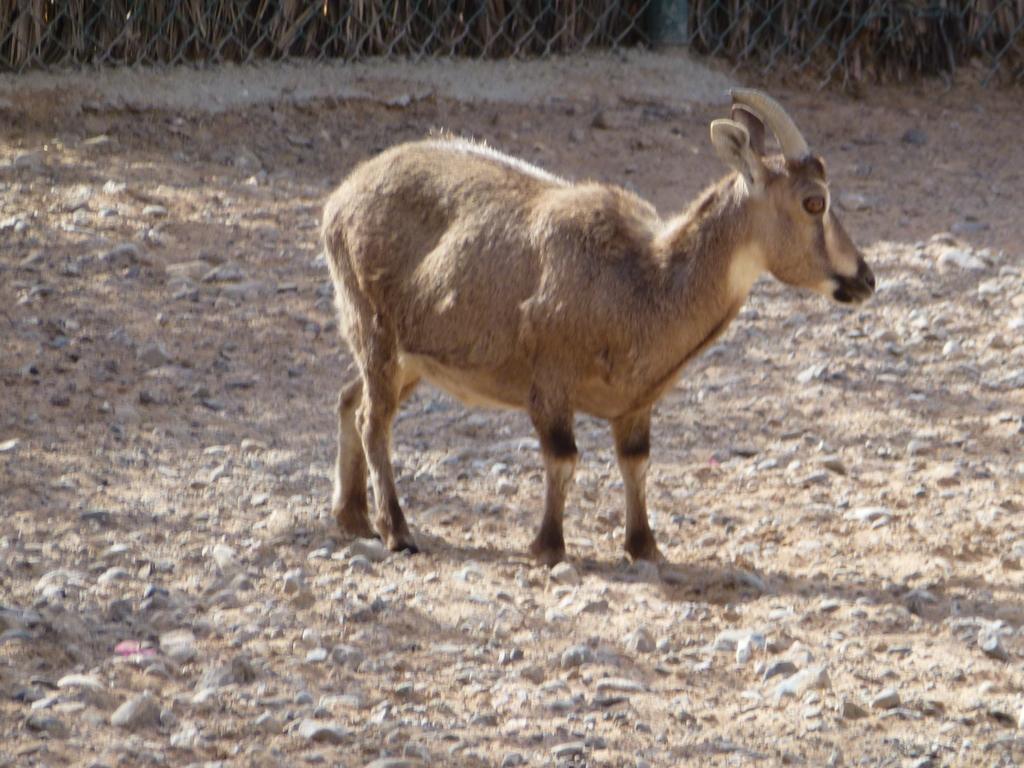Could you give a brief overview of what you see in this image? As we can see in the image in the front there is an animal. In the background there is fence. 